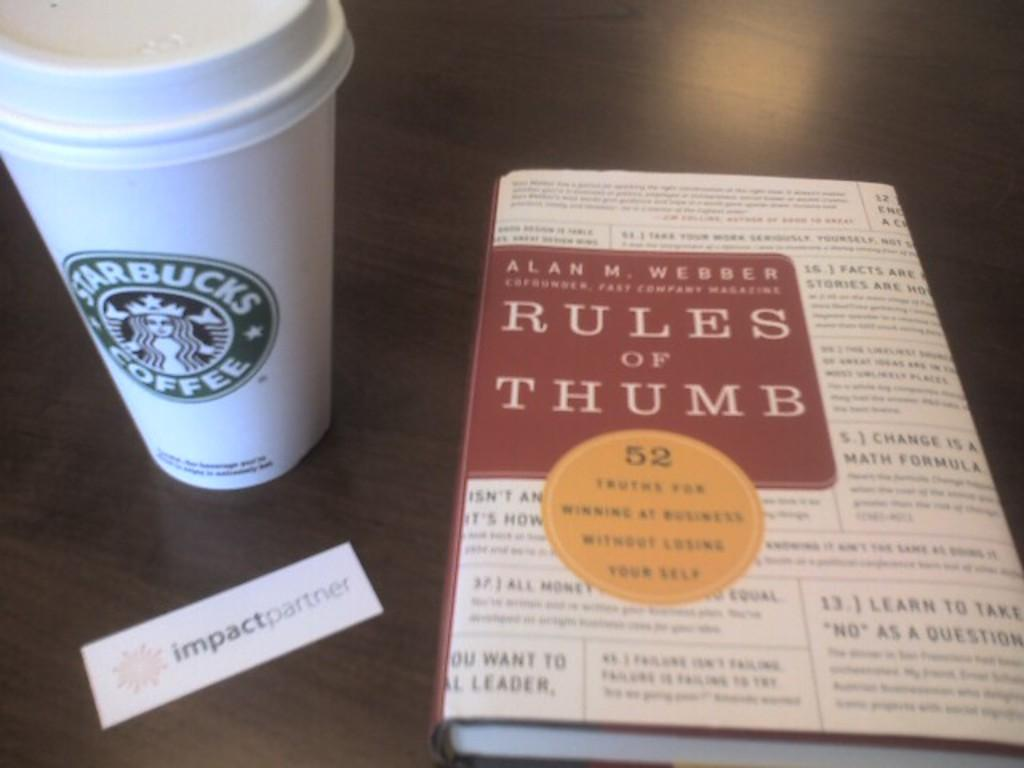What is one object that can be seen on the table in the image? There is a coffee mug in the image. What other object is present on the table in the image? There is a book in the image. Can you describe the location of both objects in the image? Both the coffee mug and the book are on a table. What type of chess piece is on the table in the image? There is no chess piece present in the image; it only features a coffee mug and a book on a table. How can you tell if the coffee mug is too hot to touch in the image? The image does not provide any information about the temperature of the coffee mug, so it cannot be determined from the image. 